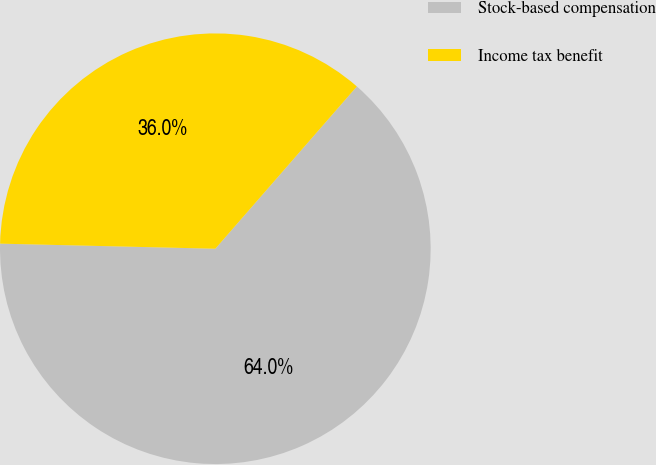Convert chart. <chart><loc_0><loc_0><loc_500><loc_500><pie_chart><fcel>Stock-based compensation<fcel>Income tax benefit<nl><fcel>63.96%<fcel>36.04%<nl></chart> 